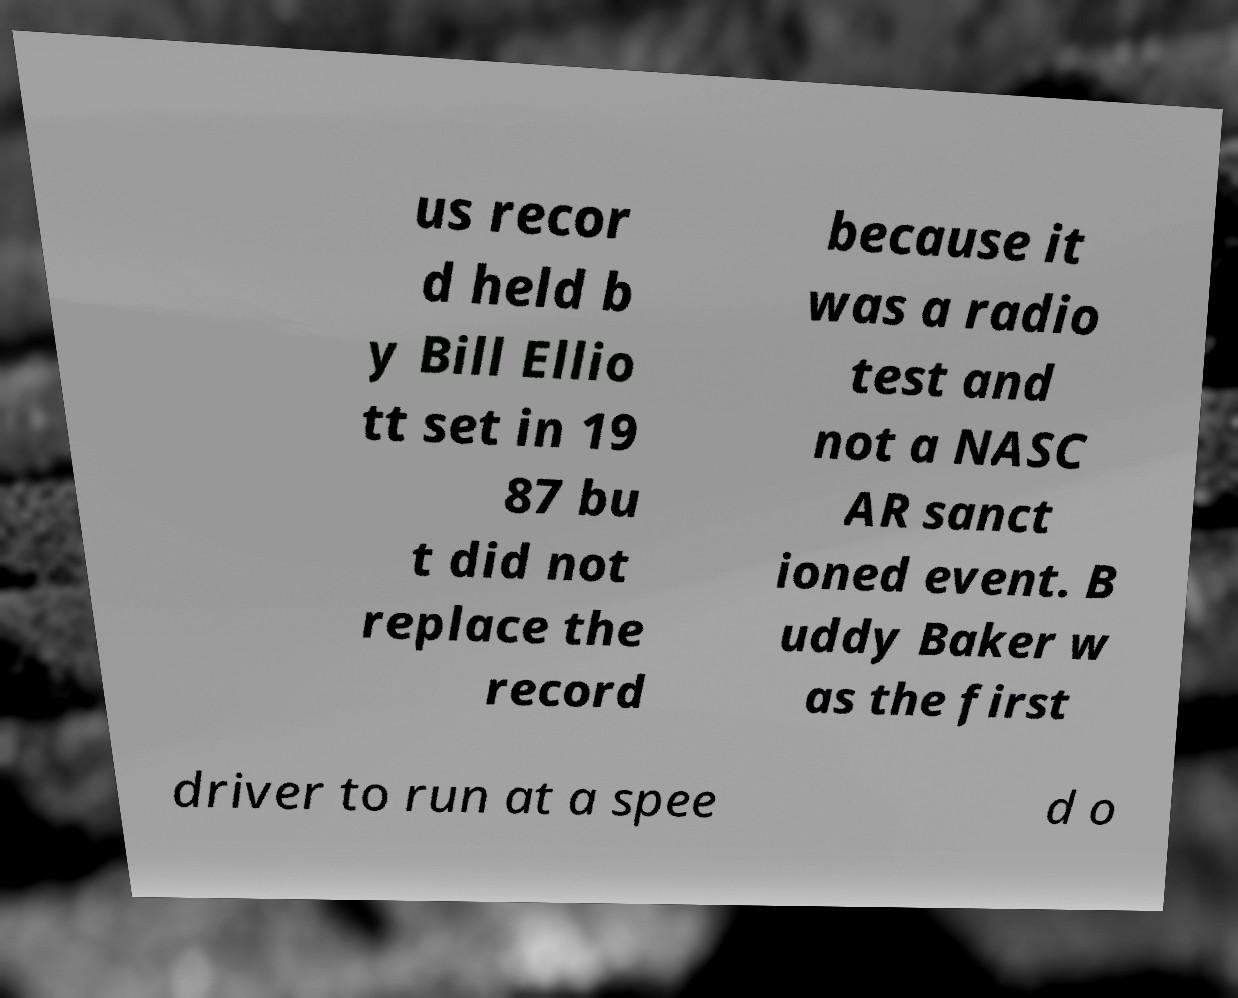Could you extract and type out the text from this image? us recor d held b y Bill Ellio tt set in 19 87 bu t did not replace the record because it was a radio test and not a NASC AR sanct ioned event. B uddy Baker w as the first driver to run at a spee d o 